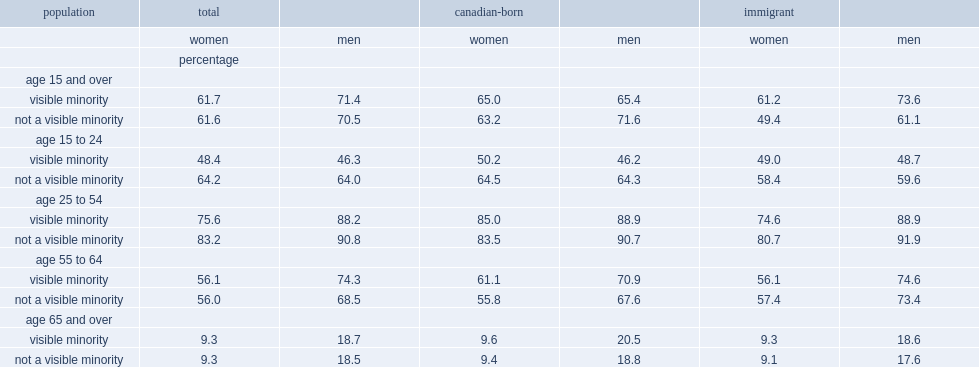In 2011, what was the percentage of women aged 15 and over were labour force participants, regardless of visible minority status? 61.7. In 2011, what was the percentage of men aged 15 and over were labour force participants, regardless of visible minority status? 71.4. Among young adults between the ages of 15 and 24, which type of women were less likely to be labour force participants, visible minority or not a visible minority? Visible minority. In the core working-age group of 25- to 54-year-olds, which type of women were less likely than to be labour force participants, visible minority or not a visible minority? Visible minority. What was the percentag of whom were labour force participants carried primarily by visible minority immigrant women? 74.6. Among the canadian-born population aged 25 to 54, which type of women were slightly more likely to be labour force participants, visible minority or not a visible minority? Visible minority. Among the older working-age group of 55- to 64-year-olds, which type of canadian-born women had a somewhat higher participation rate, visible minority or not a visible minority? Visible minority. 